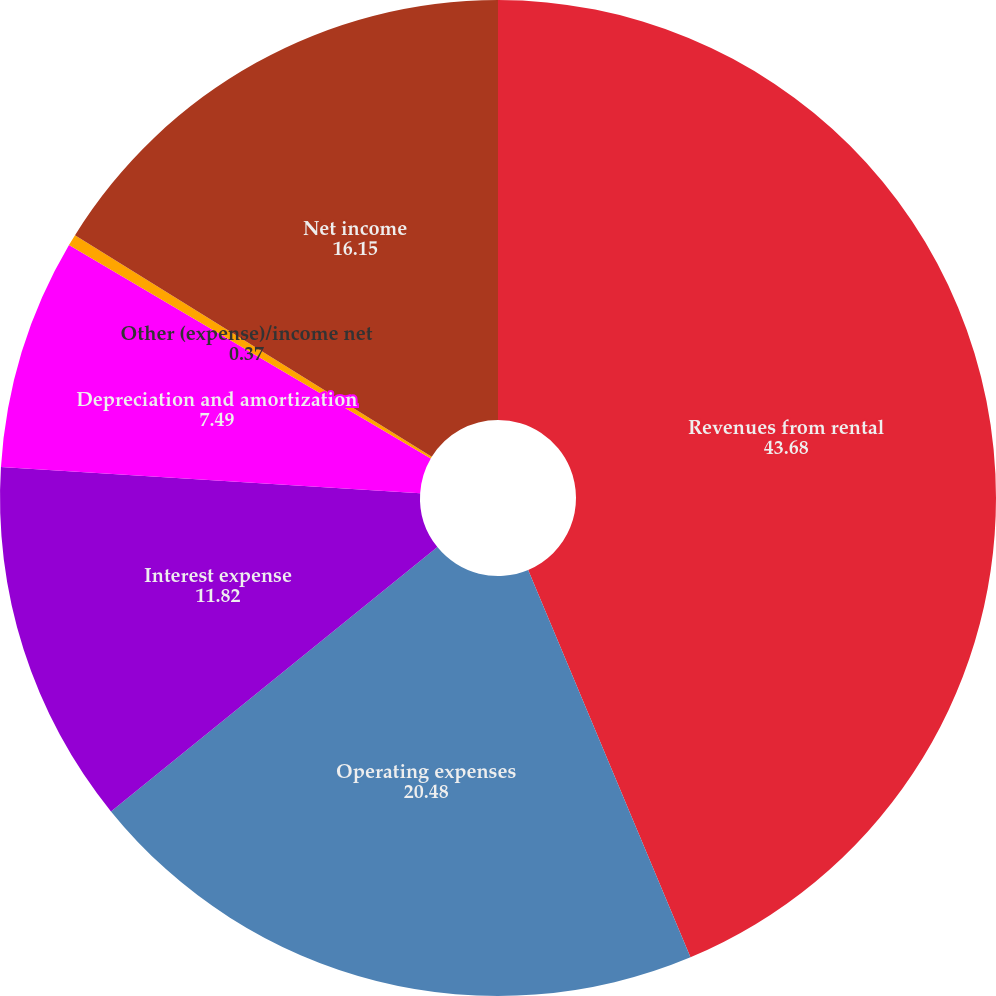Convert chart to OTSL. <chart><loc_0><loc_0><loc_500><loc_500><pie_chart><fcel>Revenues from rental<fcel>Operating expenses<fcel>Interest expense<fcel>Depreciation and amortization<fcel>Other (expense)/income net<fcel>Net income<nl><fcel>43.68%<fcel>20.48%<fcel>11.82%<fcel>7.49%<fcel>0.37%<fcel>16.15%<nl></chart> 